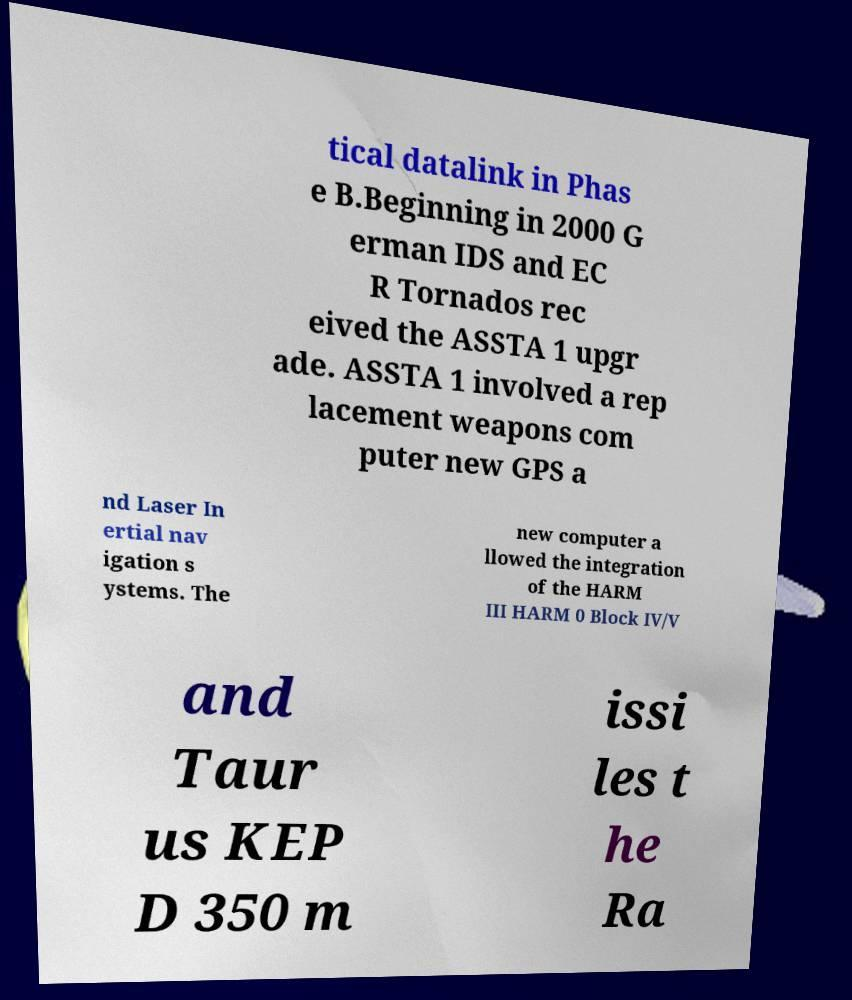Could you assist in decoding the text presented in this image and type it out clearly? tical datalink in Phas e B.Beginning in 2000 G erman IDS and EC R Tornados rec eived the ASSTA 1 upgr ade. ASSTA 1 involved a rep lacement weapons com puter new GPS a nd Laser In ertial nav igation s ystems. The new computer a llowed the integration of the HARM III HARM 0 Block IV/V and Taur us KEP D 350 m issi les t he Ra 